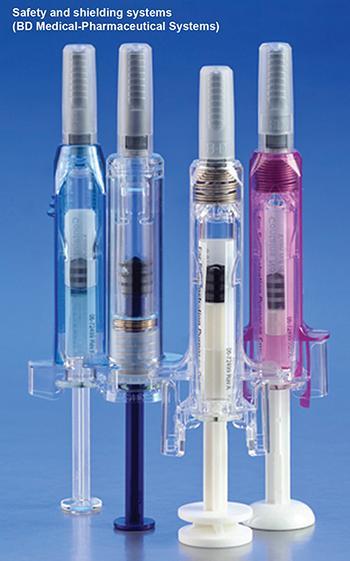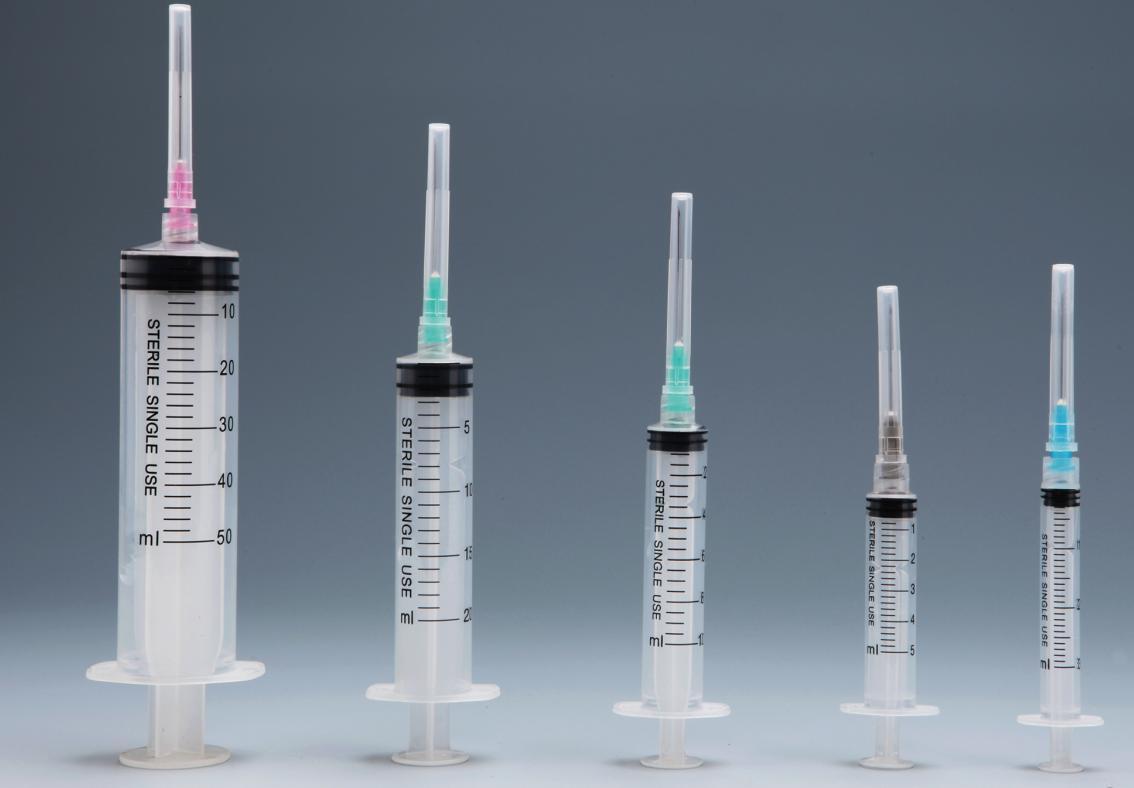The first image is the image on the left, the second image is the image on the right. Considering the images on both sides, is "At least one image is of a row of syringes standing on their stoppers." valid? Answer yes or no. Yes. 